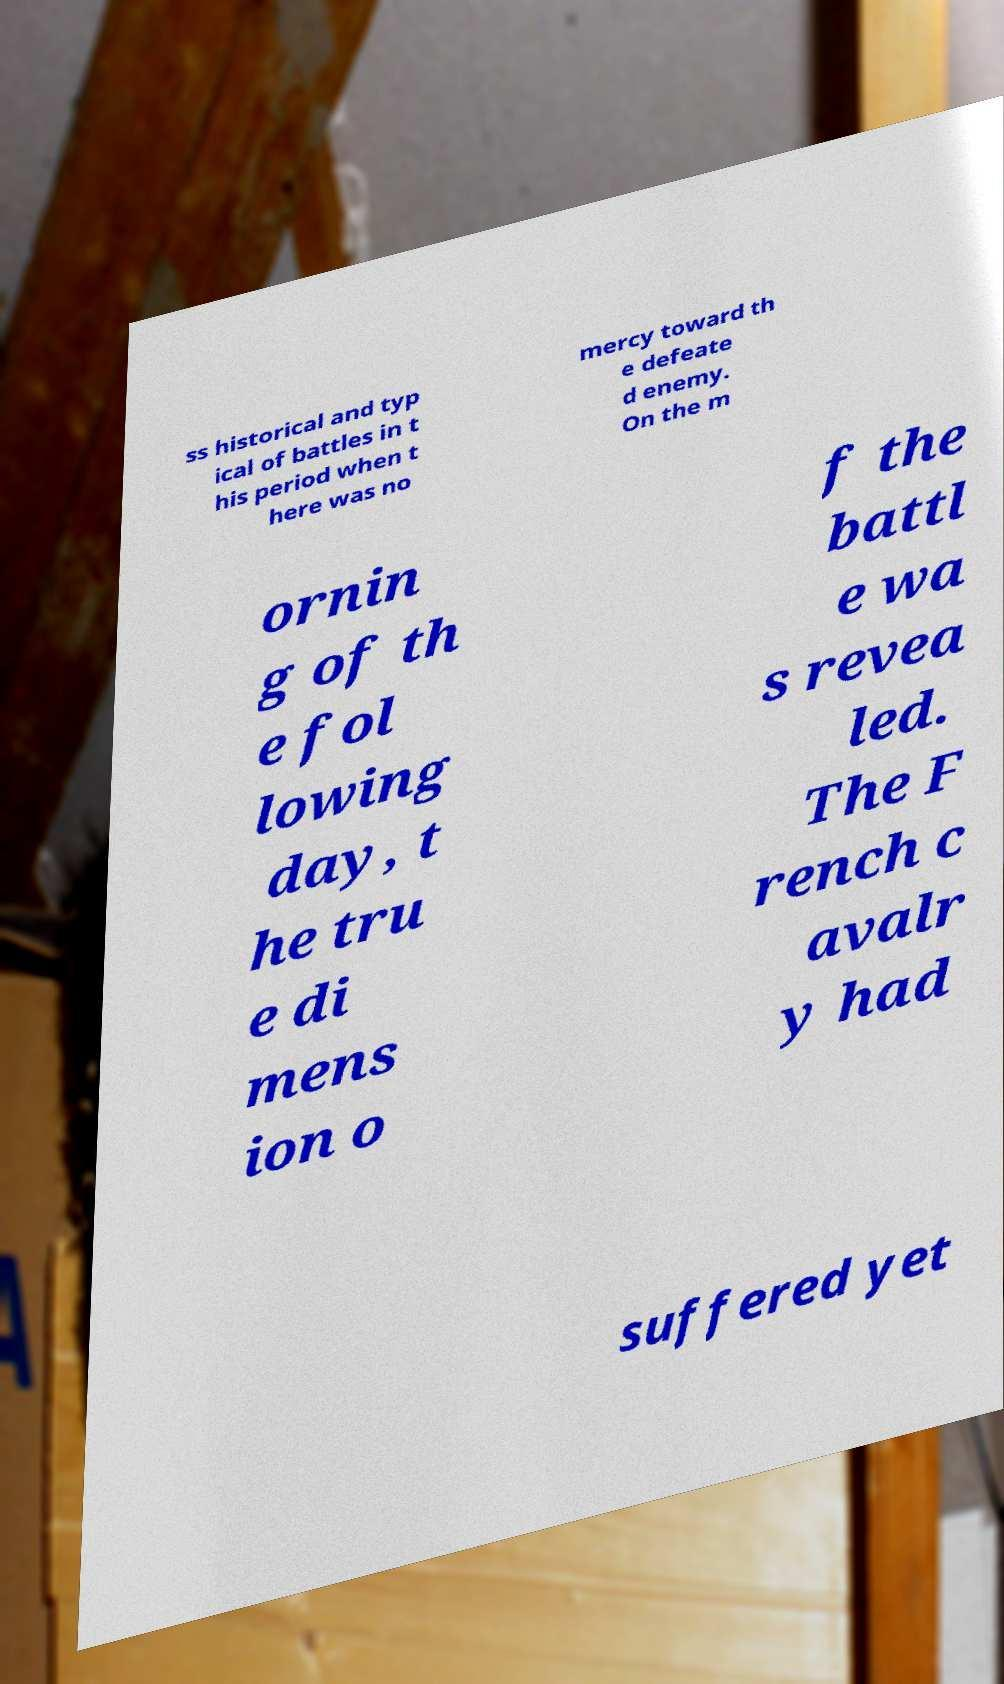Can you read and provide the text displayed in the image?This photo seems to have some interesting text. Can you extract and type it out for me? ss historical and typ ical of battles in t his period when t here was no mercy toward th e defeate d enemy. On the m ornin g of th e fol lowing day, t he tru e di mens ion o f the battl e wa s revea led. The F rench c avalr y had suffered yet 